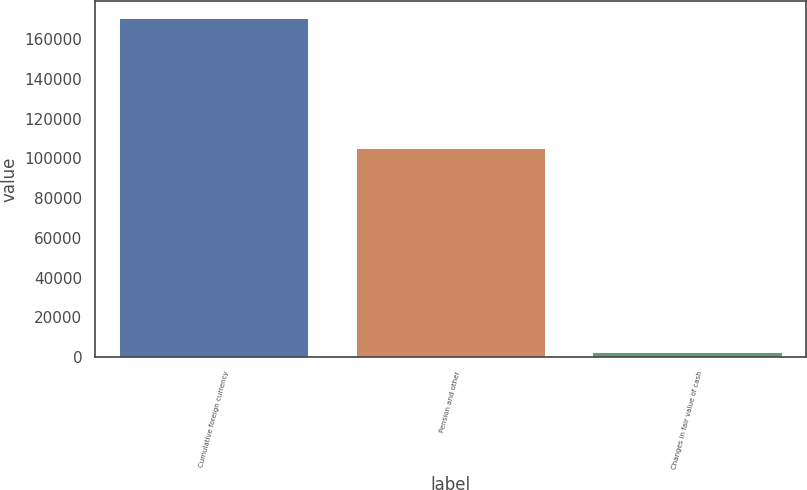Convert chart to OTSL. <chart><loc_0><loc_0><loc_500><loc_500><bar_chart><fcel>Cumulative foreign currency<fcel>Pension and other<fcel>Changes in fair value of cash<nl><fcel>170608<fcel>105380<fcel>2495<nl></chart> 